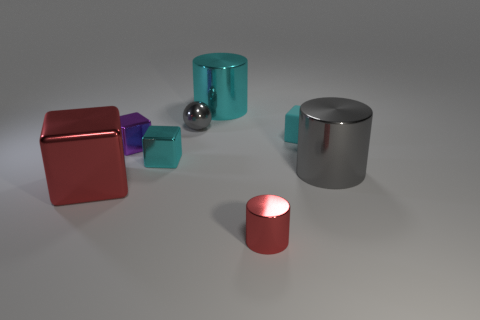Subtract all cyan metal blocks. How many blocks are left? 3 Subtract all blue spheres. How many cyan cubes are left? 2 Subtract all purple cubes. How many cubes are left? 3 Subtract 1 cubes. How many cubes are left? 3 Add 1 big cyan cubes. How many objects exist? 9 Subtract all brown blocks. Subtract all red spheres. How many blocks are left? 4 Subtract all tiny cyan objects. Subtract all tiny shiny balls. How many objects are left? 5 Add 5 matte things. How many matte things are left? 6 Add 2 small red things. How many small red things exist? 3 Subtract 0 yellow cubes. How many objects are left? 8 